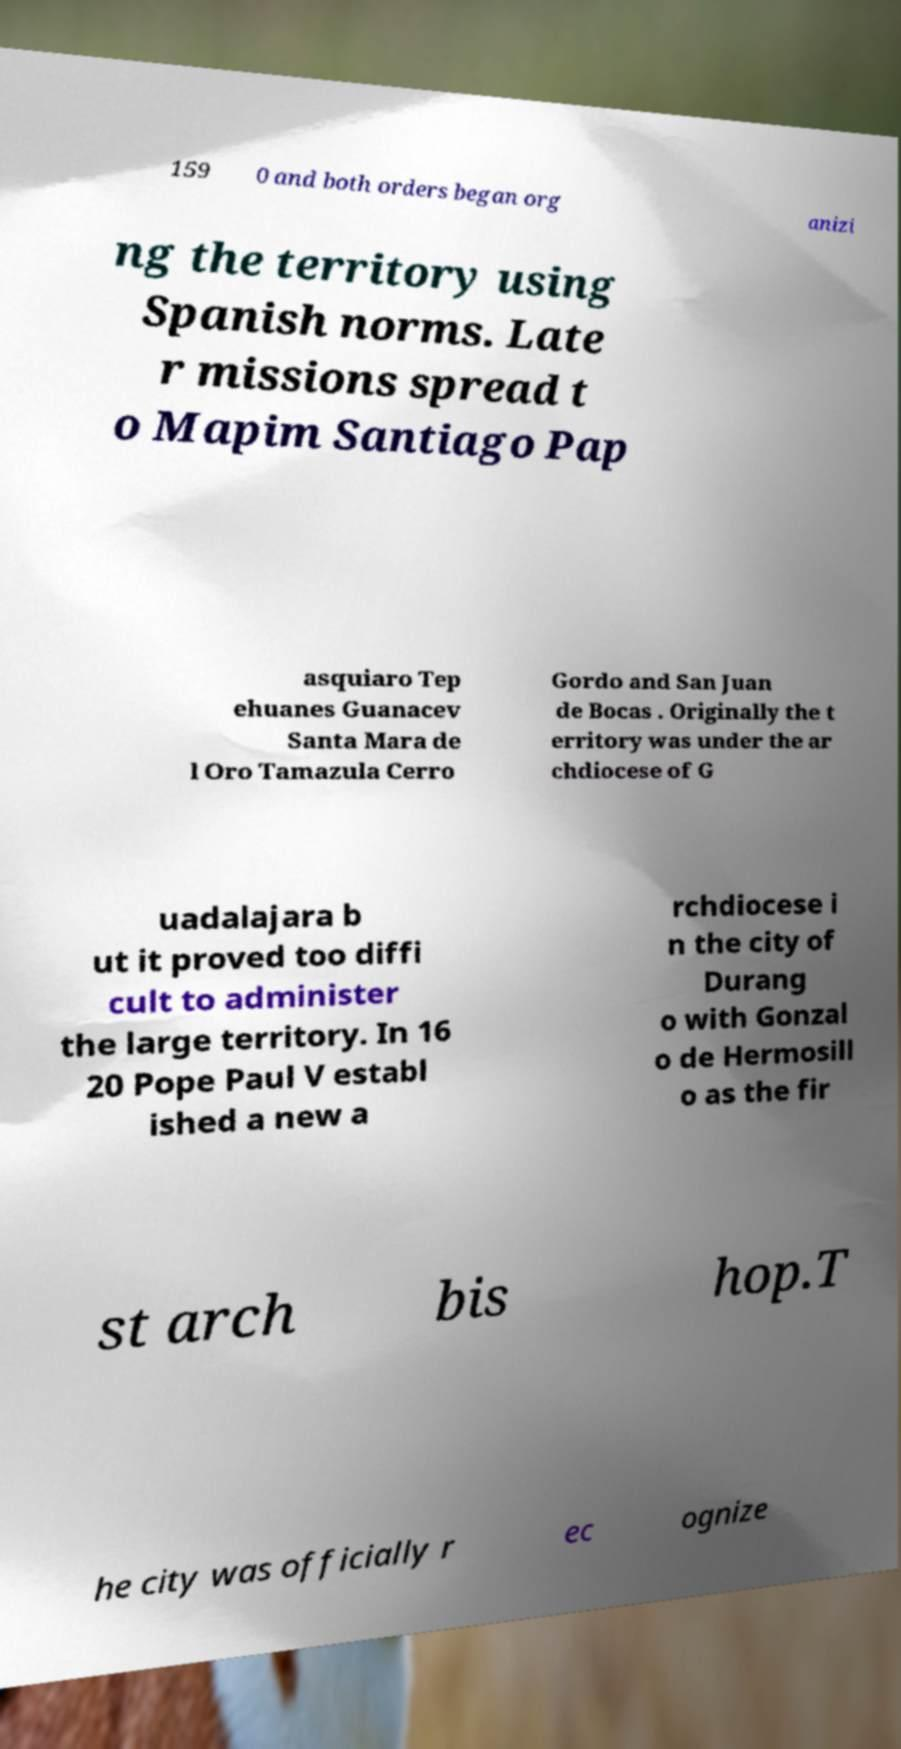What messages or text are displayed in this image? I need them in a readable, typed format. 159 0 and both orders began org anizi ng the territory using Spanish norms. Late r missions spread t o Mapim Santiago Pap asquiaro Tep ehuanes Guanacev Santa Mara de l Oro Tamazula Cerro Gordo and San Juan de Bocas . Originally the t erritory was under the ar chdiocese of G uadalajara b ut it proved too diffi cult to administer the large territory. In 16 20 Pope Paul V establ ished a new a rchdiocese i n the city of Durang o with Gonzal o de Hermosill o as the fir st arch bis hop.T he city was officially r ec ognize 